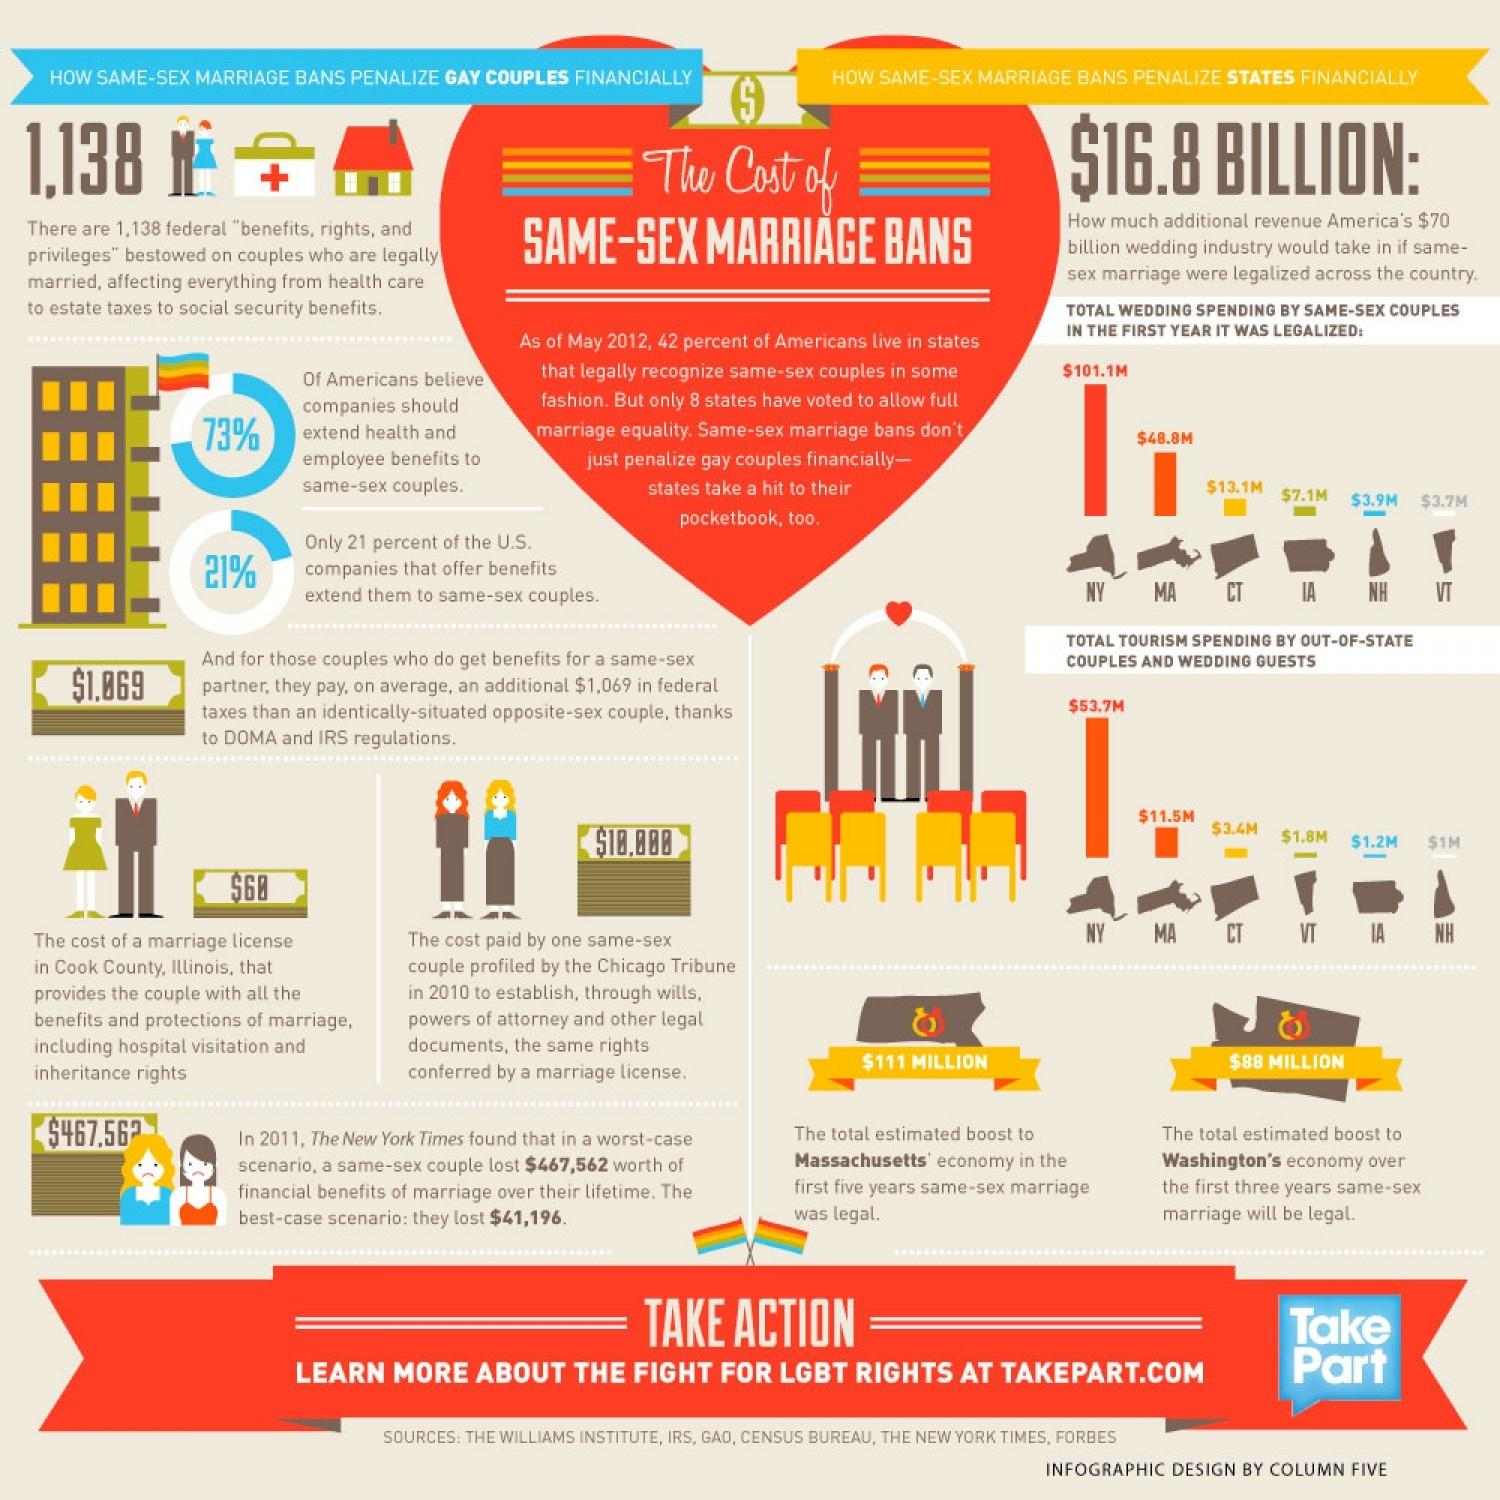Identify some key points in this picture. The total estimated boost to Washington's economy in the first three years of same-sex marriage being legal was $88 million. According to a recent survey, 79% of U.S companies do not offer benefits that extend to same-sex couples. According to a recent survey, it was found that approximately 27% of Americans do not believe that companies should extend benefits to same-sex couples. According to estimates, the legalization of same-sex marriage in Massachusetts resulted in a total estimated boost to the state's economy of $111 million in the first five years. 